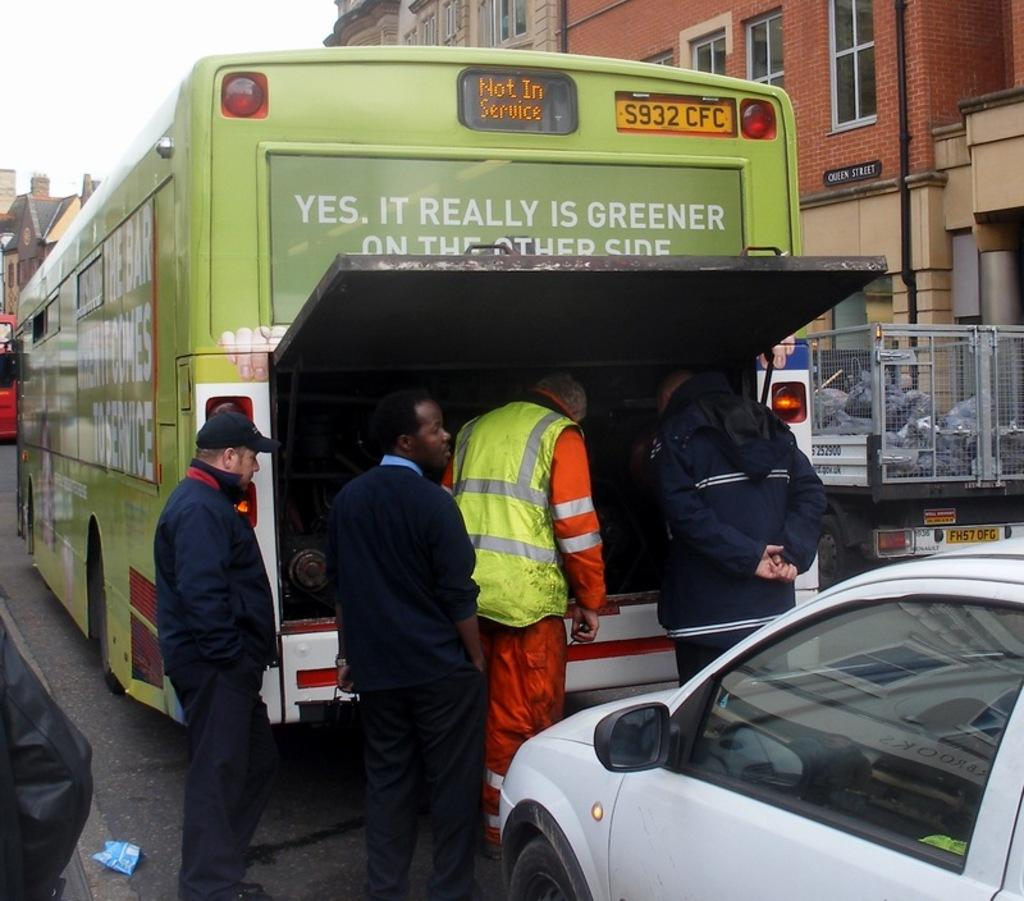<image>
Give a short and clear explanation of the subsequent image. Several men look in the engine on the back of a bus that says Yes it is really greener on the other side. 